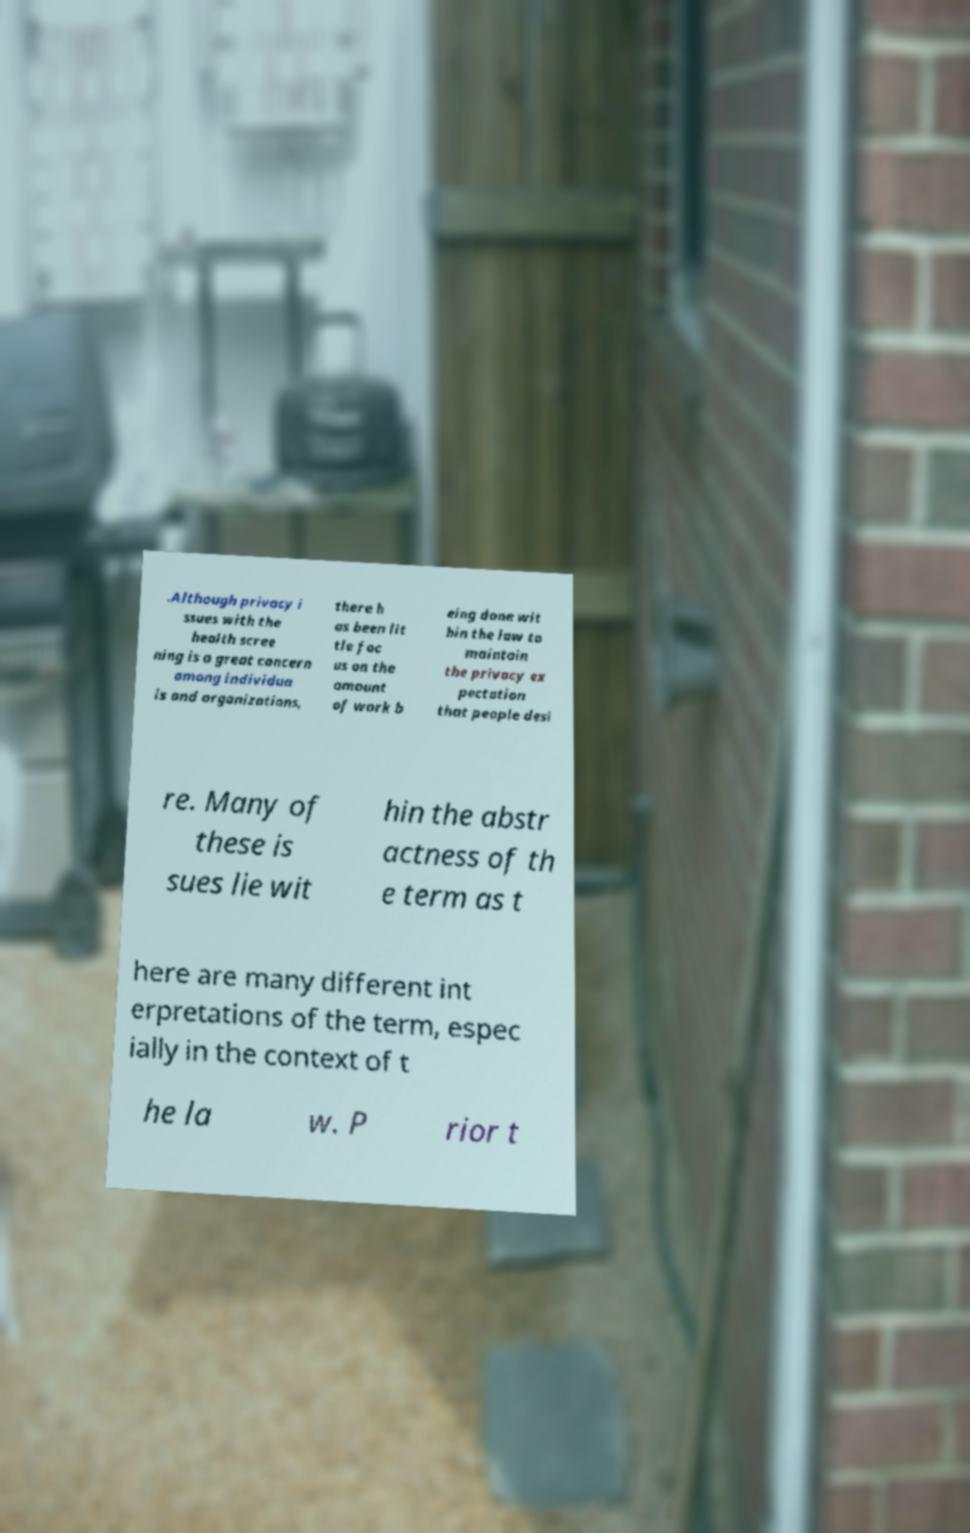What messages or text are displayed in this image? I need them in a readable, typed format. .Although privacy i ssues with the health scree ning is a great concern among individua ls and organizations, there h as been lit tle foc us on the amount of work b eing done wit hin the law to maintain the privacy ex pectation that people desi re. Many of these is sues lie wit hin the abstr actness of th e term as t here are many different int erpretations of the term, espec ially in the context of t he la w. P rior t 